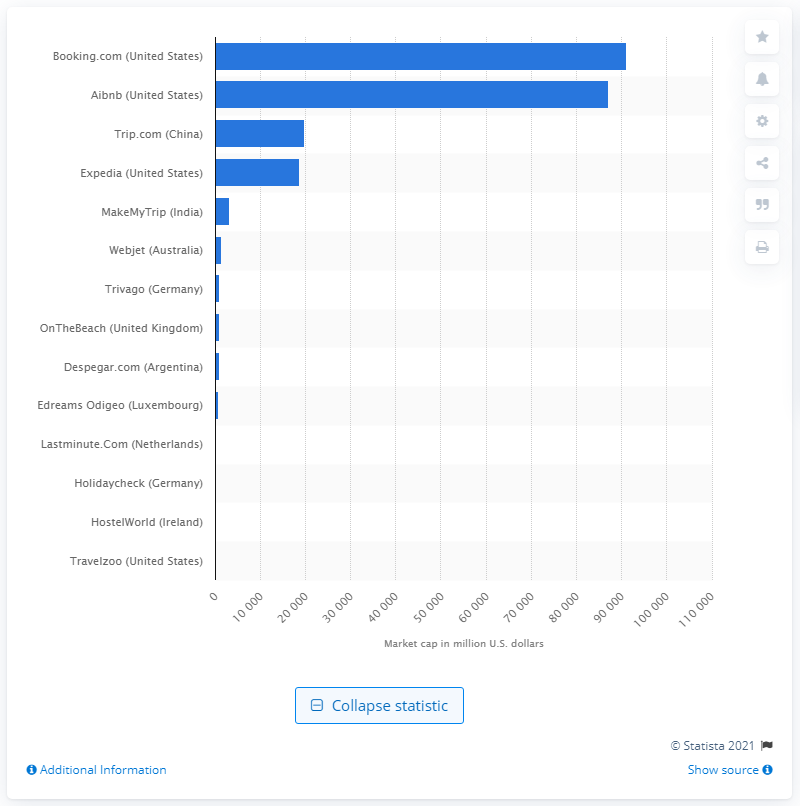Highlight a few significant elements in this photo. In December of 2020, Airbnb's market capitalization was approximately $870,890,000 in dollars. Booking.com has a market capitalization of 91,218. 